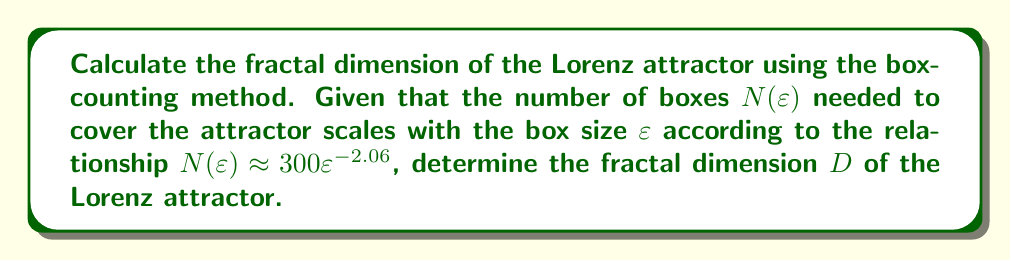Could you help me with this problem? To determine the fractal dimension of the Lorenz attractor using the box-counting method, we'll follow these steps:

1. Recall the box-counting dimension formula:
   $$D = \lim_{\varepsilon \to 0} \frac{\log N(\varepsilon)}{\log(1/\varepsilon)}$$

2. We're given that $N(\varepsilon) \approx 300\varepsilon^{-2.06}$. Let's substitute this into the formula:
   $$D = \lim_{\varepsilon \to 0} \frac{\log(300\varepsilon^{-2.06})}{\log(1/\varepsilon)}$$

3. Use the logarithm properties to simplify:
   $$D = \lim_{\varepsilon \to 0} \frac{\log(300) + \log(\varepsilon^{-2.06})}{\log(1/\varepsilon)}$$
   $$D = \lim_{\varepsilon \to 0} \frac{\log(300) - 2.06\log(\varepsilon)}{\log(1/\varepsilon)}$$

4. As $\varepsilon \to 0$, $\log(300)$ becomes negligible compared to $\log(\varepsilon)$, so we can simplify:
   $$D = \lim_{\varepsilon \to 0} \frac{-2.06\log(\varepsilon)}{\log(1/\varepsilon)}$$

5. Note that $\log(1/\varepsilon) = -\log(\varepsilon)$, so:
   $$D = \lim_{\varepsilon \to 0} \frac{-2.06\log(\varepsilon)}{-\log(\varepsilon)} = 2.06$$

Therefore, the fractal dimension of the Lorenz attractor is 2.06.
Answer: 2.06 